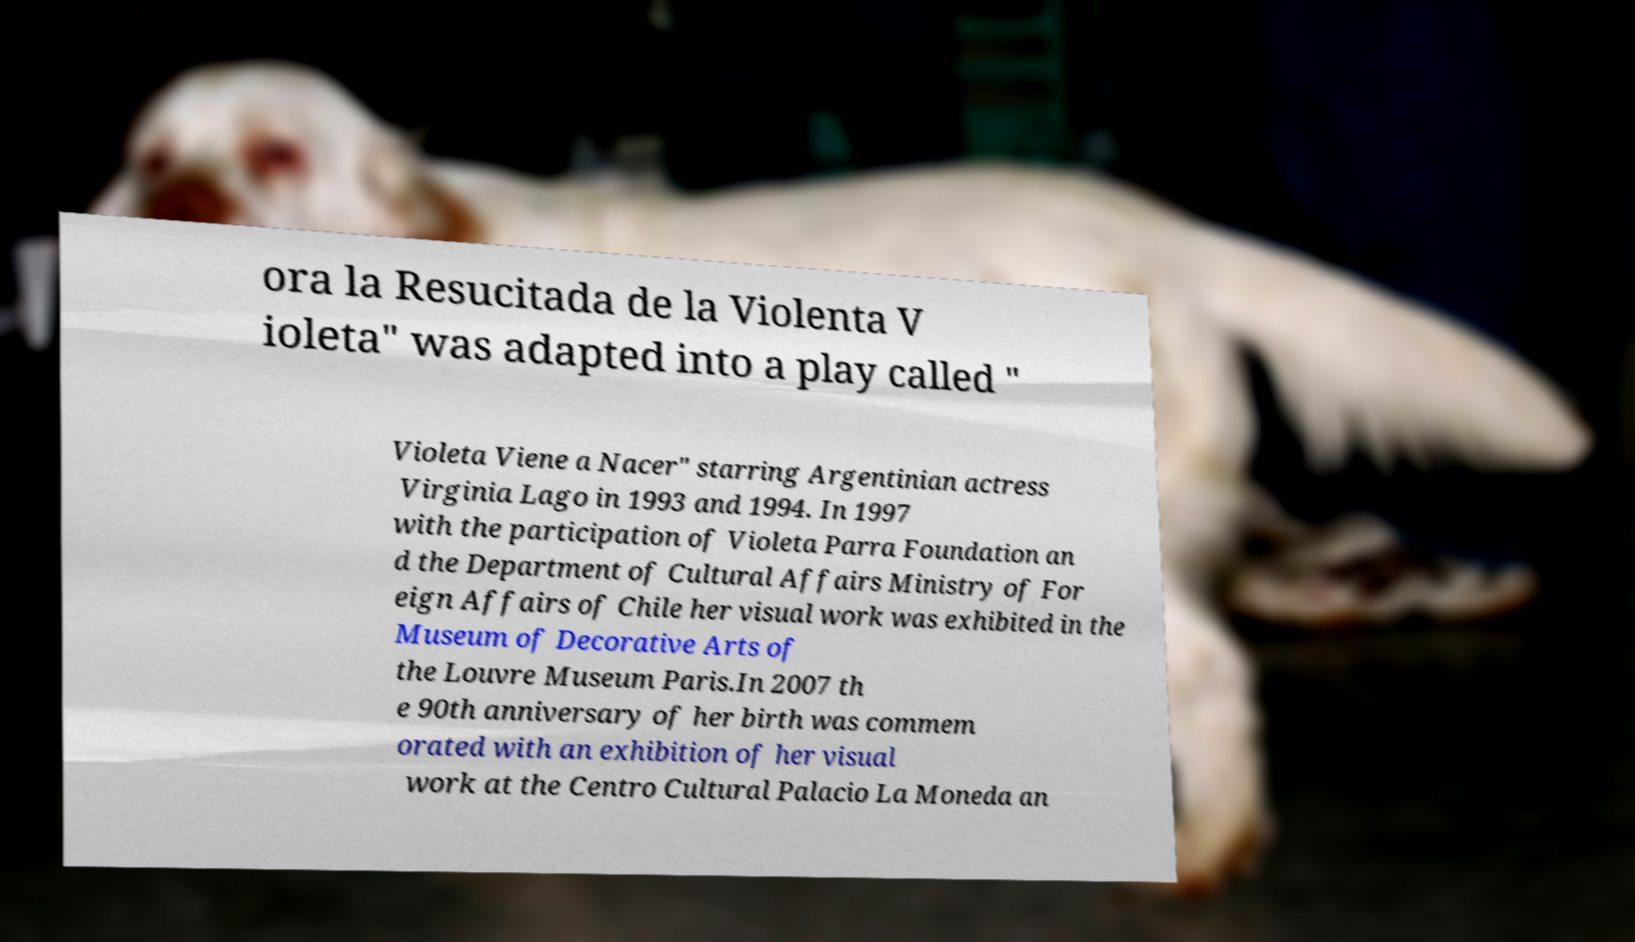There's text embedded in this image that I need extracted. Can you transcribe it verbatim? ora la Resucitada de la Violenta V ioleta" was adapted into a play called " Violeta Viene a Nacer" starring Argentinian actress Virginia Lago in 1993 and 1994. In 1997 with the participation of Violeta Parra Foundation an d the Department of Cultural Affairs Ministry of For eign Affairs of Chile her visual work was exhibited in the Museum of Decorative Arts of the Louvre Museum Paris.In 2007 th e 90th anniversary of her birth was commem orated with an exhibition of her visual work at the Centro Cultural Palacio La Moneda an 